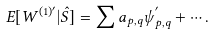<formula> <loc_0><loc_0><loc_500><loc_500>E [ W ^ { ( 1 ) ^ { \prime } } | \hat { S } ] = \sum a _ { p , q } \psi _ { p , q } ^ { ^ { \prime } } + \cdots .</formula> 